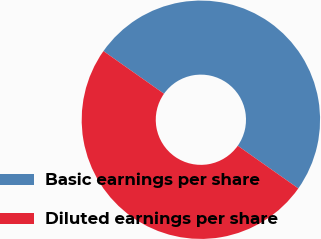Convert chart to OTSL. <chart><loc_0><loc_0><loc_500><loc_500><pie_chart><fcel>Basic earnings per share<fcel>Diluted earnings per share<nl><fcel>50.0%<fcel>50.0%<nl></chart> 